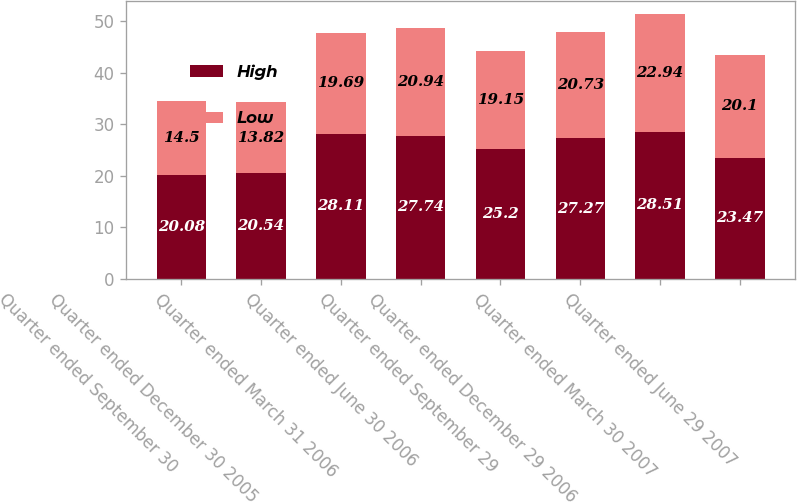<chart> <loc_0><loc_0><loc_500><loc_500><stacked_bar_chart><ecel><fcel>Quarter ended September 30<fcel>Quarter ended December 30 2005<fcel>Quarter ended March 31 2006<fcel>Quarter ended June 30 2006<fcel>Quarter ended September 29<fcel>Quarter ended December 29 2006<fcel>Quarter ended March 30 2007<fcel>Quarter ended June 29 2007<nl><fcel>High<fcel>20.08<fcel>20.54<fcel>28.11<fcel>27.74<fcel>25.2<fcel>27.27<fcel>28.51<fcel>23.47<nl><fcel>Low<fcel>14.5<fcel>13.82<fcel>19.69<fcel>20.94<fcel>19.15<fcel>20.73<fcel>22.94<fcel>20.1<nl></chart> 